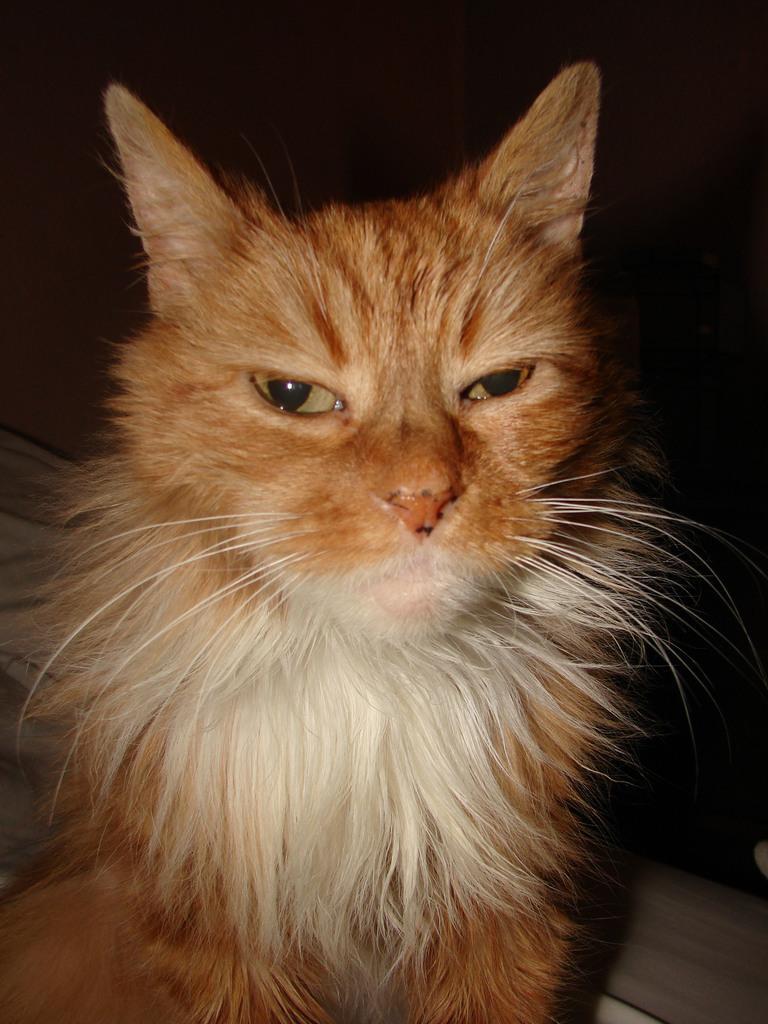Can you describe this image briefly? In this image there is a cat. 